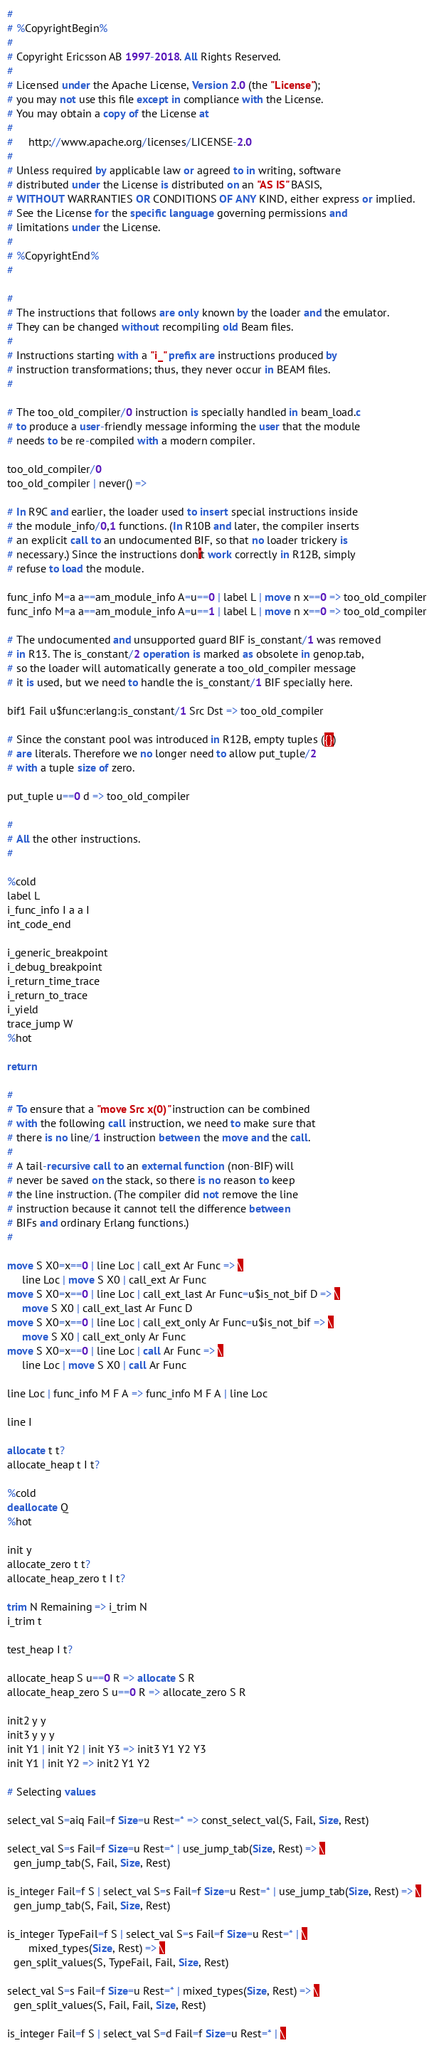Convert code to text. <code><loc_0><loc_0><loc_500><loc_500><_SQL_>#
# %CopyrightBegin%
#
# Copyright Ericsson AB 1997-2018. All Rights Reserved.
#
# Licensed under the Apache License, Version 2.0 (the "License");
# you may not use this file except in compliance with the License.
# You may obtain a copy of the License at
#
#     http://www.apache.org/licenses/LICENSE-2.0
#
# Unless required by applicable law or agreed to in writing, software
# distributed under the License is distributed on an "AS IS" BASIS,
# WITHOUT WARRANTIES OR CONDITIONS OF ANY KIND, either express or implied.
# See the License for the specific language governing permissions and
# limitations under the License.
#
# %CopyrightEnd%
#

#
# The instructions that follows are only known by the loader and the emulator.
# They can be changed without recompiling old Beam files.
#
# Instructions starting with a "i_" prefix are instructions produced by
# instruction transformations; thus, they never occur in BEAM files.
#

# The too_old_compiler/0 instruction is specially handled in beam_load.c
# to produce a user-friendly message informing the user that the module
# needs to be re-compiled with a modern compiler.

too_old_compiler/0
too_old_compiler | never() =>

# In R9C and earlier, the loader used to insert special instructions inside
# the module_info/0,1 functions. (In R10B and later, the compiler inserts
# an explicit call to an undocumented BIF, so that no loader trickery is
# necessary.) Since the instructions don't work correctly in R12B, simply
# refuse to load the module.

func_info M=a a==am_module_info A=u==0 | label L | move n x==0 => too_old_compiler
func_info M=a a==am_module_info A=u==1 | label L | move n x==0 => too_old_compiler

# The undocumented and unsupported guard BIF is_constant/1 was removed
# in R13. The is_constant/2 operation is marked as obsolete in genop.tab,
# so the loader will automatically generate a too_old_compiler message
# it is used, but we need to handle the is_constant/1 BIF specially here.

bif1 Fail u$func:erlang:is_constant/1 Src Dst => too_old_compiler

# Since the constant pool was introduced in R12B, empty tuples ({})
# are literals. Therefore we no longer need to allow put_tuple/2
# with a tuple size of zero.

put_tuple u==0 d => too_old_compiler

#
# All the other instructions.
#

%cold
label L
i_func_info I a a I
int_code_end

i_generic_breakpoint
i_debug_breakpoint
i_return_time_trace
i_return_to_trace
i_yield
trace_jump W
%hot

return

#
# To ensure that a "move Src x(0)" instruction can be combined
# with the following call instruction, we need to make sure that
# there is no line/1 instruction between the move and the call.
#
# A tail-recursive call to an external function (non-BIF) will
# never be saved on the stack, so there is no reason to keep
# the line instruction. (The compiler did not remove the line
# instruction because it cannot tell the difference between
# BIFs and ordinary Erlang functions.)
#

move S X0=x==0 | line Loc | call_ext Ar Func => \
     line Loc | move S X0 | call_ext Ar Func
move S X0=x==0 | line Loc | call_ext_last Ar Func=u$is_not_bif D => \
     move S X0 | call_ext_last Ar Func D
move S X0=x==0 | line Loc | call_ext_only Ar Func=u$is_not_bif => \
     move S X0 | call_ext_only Ar Func
move S X0=x==0 | line Loc | call Ar Func => \
     line Loc | move S X0 | call Ar Func

line Loc | func_info M F A => func_info M F A | line Loc

line I

allocate t t?
allocate_heap t I t?

%cold
deallocate Q
%hot

init y
allocate_zero t t?
allocate_heap_zero t I t?

trim N Remaining => i_trim N
i_trim t

test_heap I t?

allocate_heap S u==0 R => allocate S R
allocate_heap_zero S u==0 R => allocate_zero S R

init2 y y
init3 y y y
init Y1 | init Y2 | init Y3 => init3 Y1 Y2 Y3
init Y1 | init Y2 => init2 Y1 Y2

# Selecting values

select_val S=aiq Fail=f Size=u Rest=* => const_select_val(S, Fail, Size, Rest)

select_val S=s Fail=f Size=u Rest=* | use_jump_tab(Size, Rest) => \
  gen_jump_tab(S, Fail, Size, Rest)

is_integer Fail=f S | select_val S=s Fail=f Size=u Rest=* | use_jump_tab(Size, Rest) => \
  gen_jump_tab(S, Fail, Size, Rest)

is_integer TypeFail=f S | select_val S=s Fail=f Size=u Rest=* | \
	   mixed_types(Size, Rest) => \
  gen_split_values(S, TypeFail, Fail, Size, Rest)

select_val S=s Fail=f Size=u Rest=* | mixed_types(Size, Rest) => \
  gen_split_values(S, Fail, Fail, Size, Rest)

is_integer Fail=f S | select_val S=d Fail=f Size=u Rest=* | \</code> 